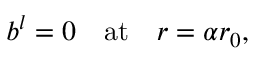Convert formula to latex. <formula><loc_0><loc_0><loc_500><loc_500>b ^ { l } = 0 \quad a t \quad r = \alpha r _ { 0 } ,</formula> 